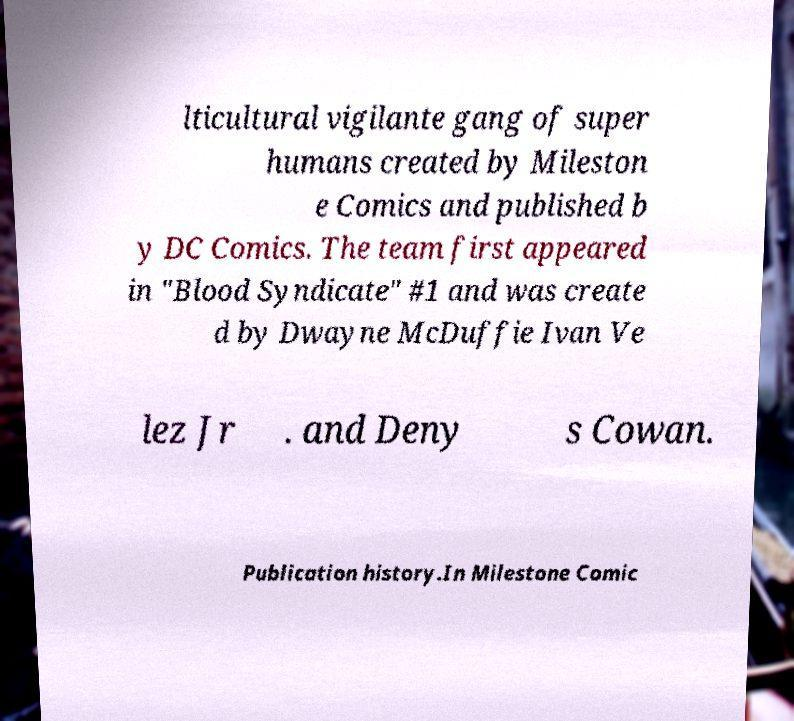Please read and relay the text visible in this image. What does it say? lticultural vigilante gang of super humans created by Mileston e Comics and published b y DC Comics. The team first appeared in "Blood Syndicate" #1 and was create d by Dwayne McDuffie Ivan Ve lez Jr . and Deny s Cowan. Publication history.In Milestone Comic 